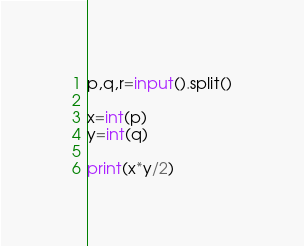Convert code to text. <code><loc_0><loc_0><loc_500><loc_500><_Python_>p,q,r=input().split()
 
x=int(p)
y=int(q)

print(x*y/2)</code> 